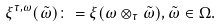<formula> <loc_0><loc_0><loc_500><loc_500>\xi ^ { \tau , \omega } ( \tilde { \omega } ) \colon = \xi ( \omega \otimes _ { \tau } \tilde { \omega } ) , \tilde { \omega } \in \Omega .</formula> 